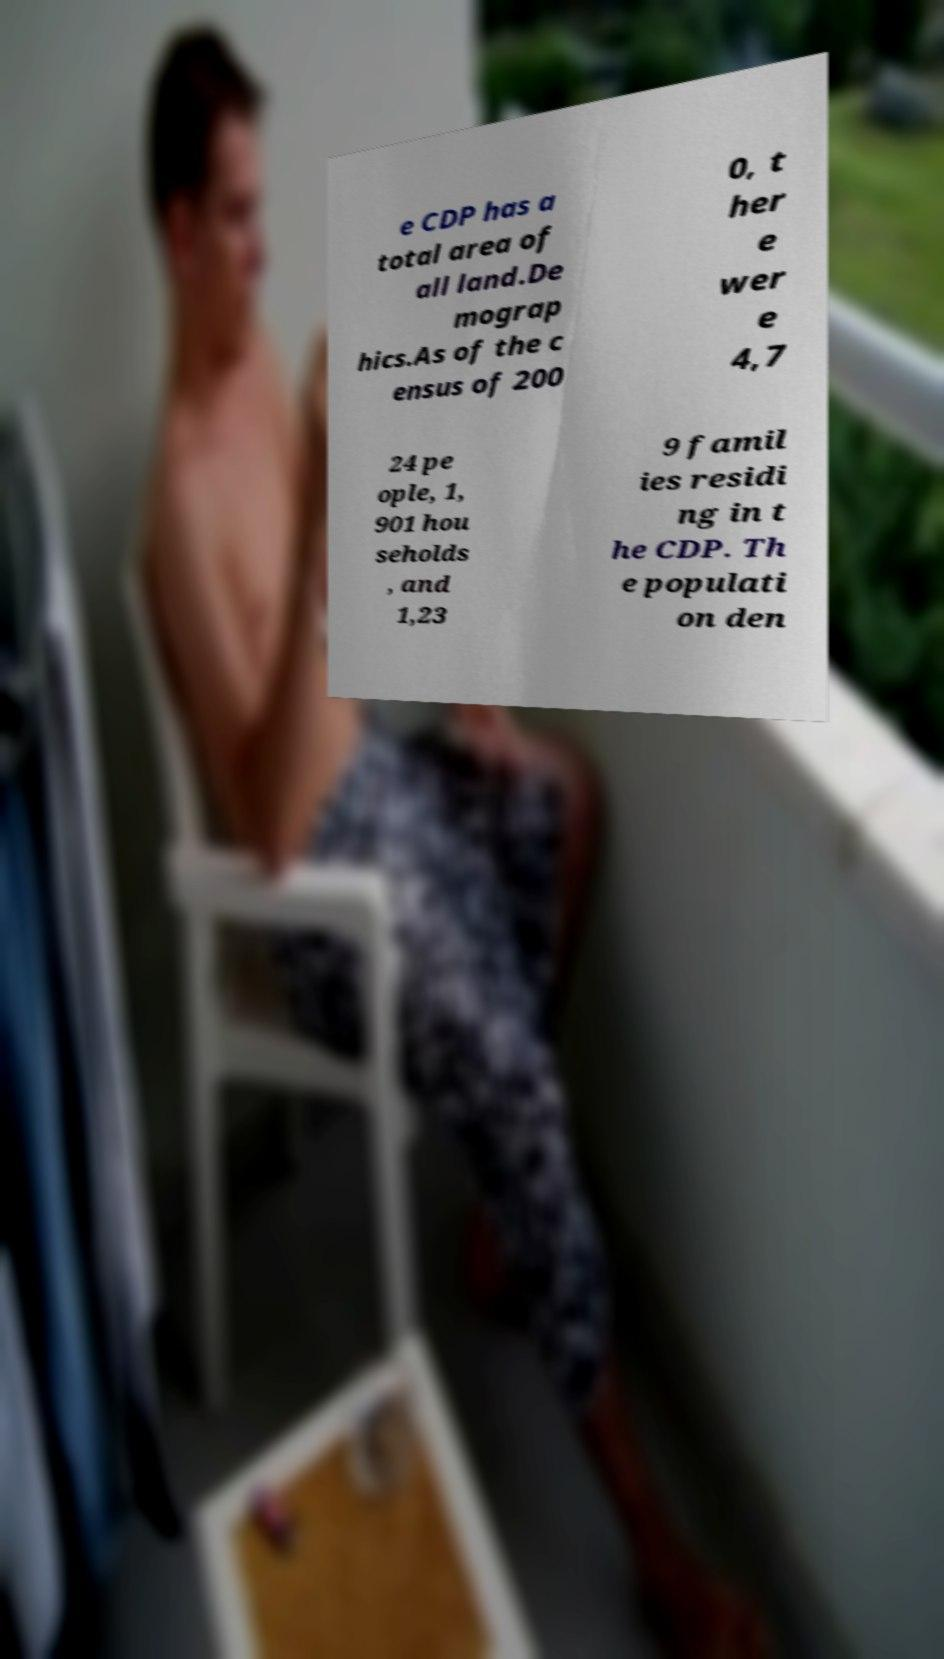Can you accurately transcribe the text from the provided image for me? e CDP has a total area of all land.De mograp hics.As of the c ensus of 200 0, t her e wer e 4,7 24 pe ople, 1, 901 hou seholds , and 1,23 9 famil ies residi ng in t he CDP. Th e populati on den 